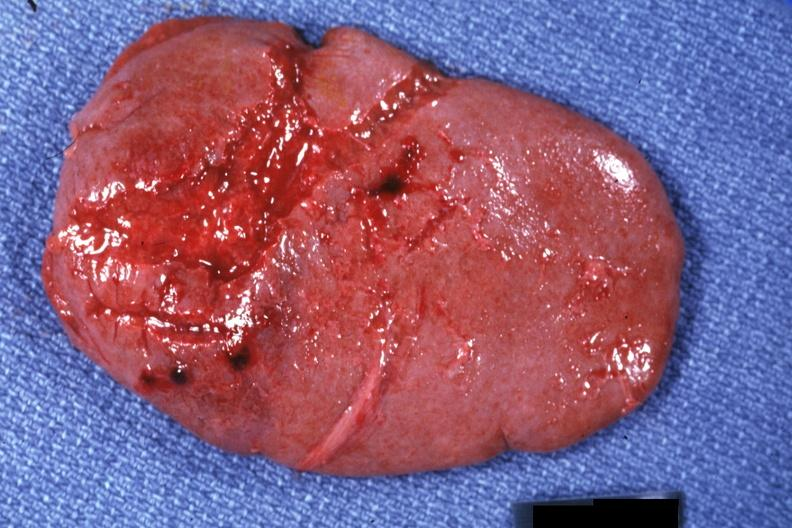s chromophobe adenoma present?
Answer the question using a single word or phrase. No 